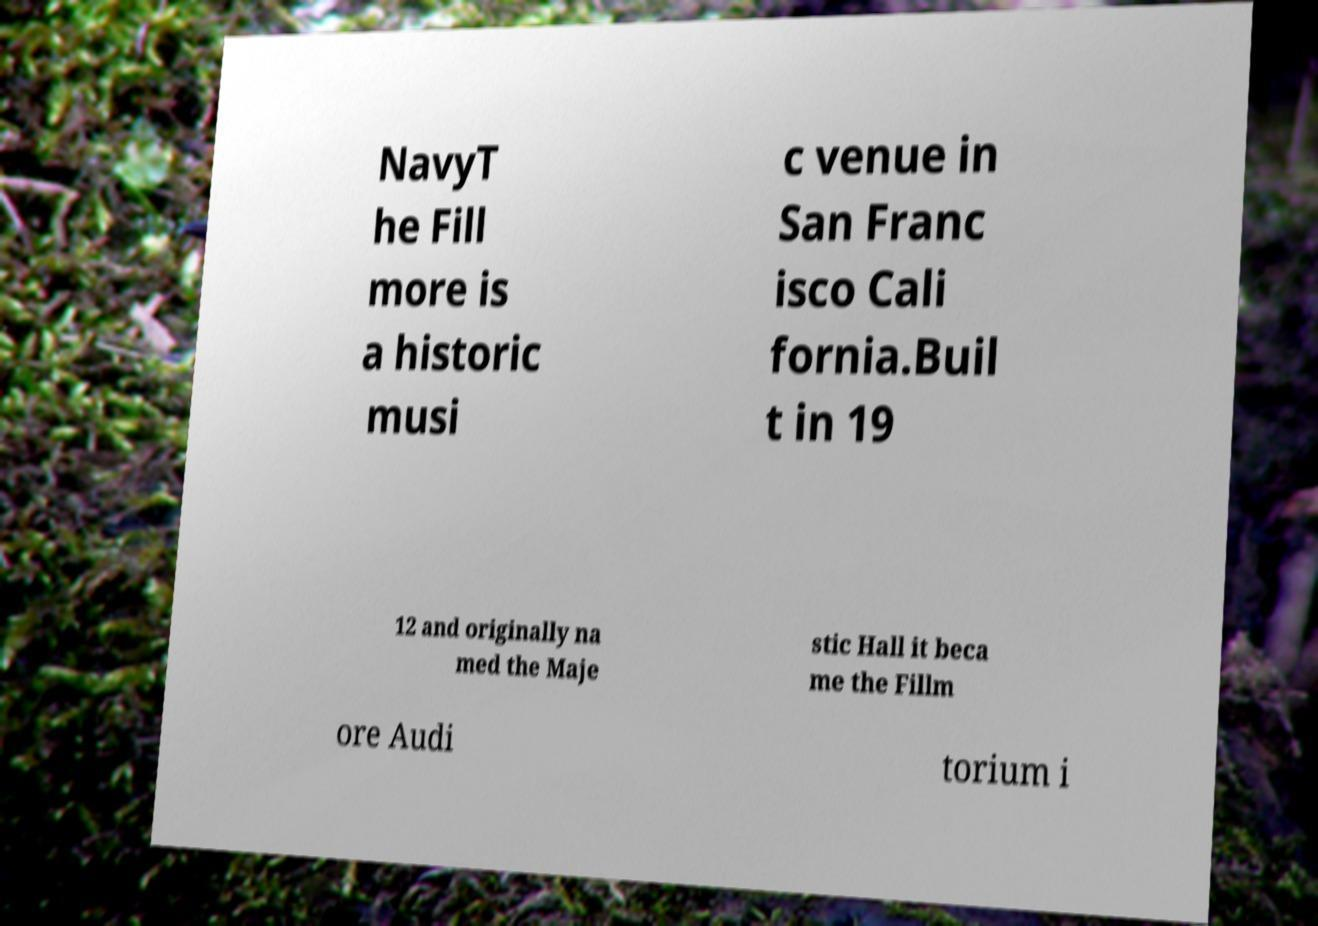What messages or text are displayed in this image? I need them in a readable, typed format. NavyT he Fill more is a historic musi c venue in San Franc isco Cali fornia.Buil t in 19 12 and originally na med the Maje stic Hall it beca me the Fillm ore Audi torium i 